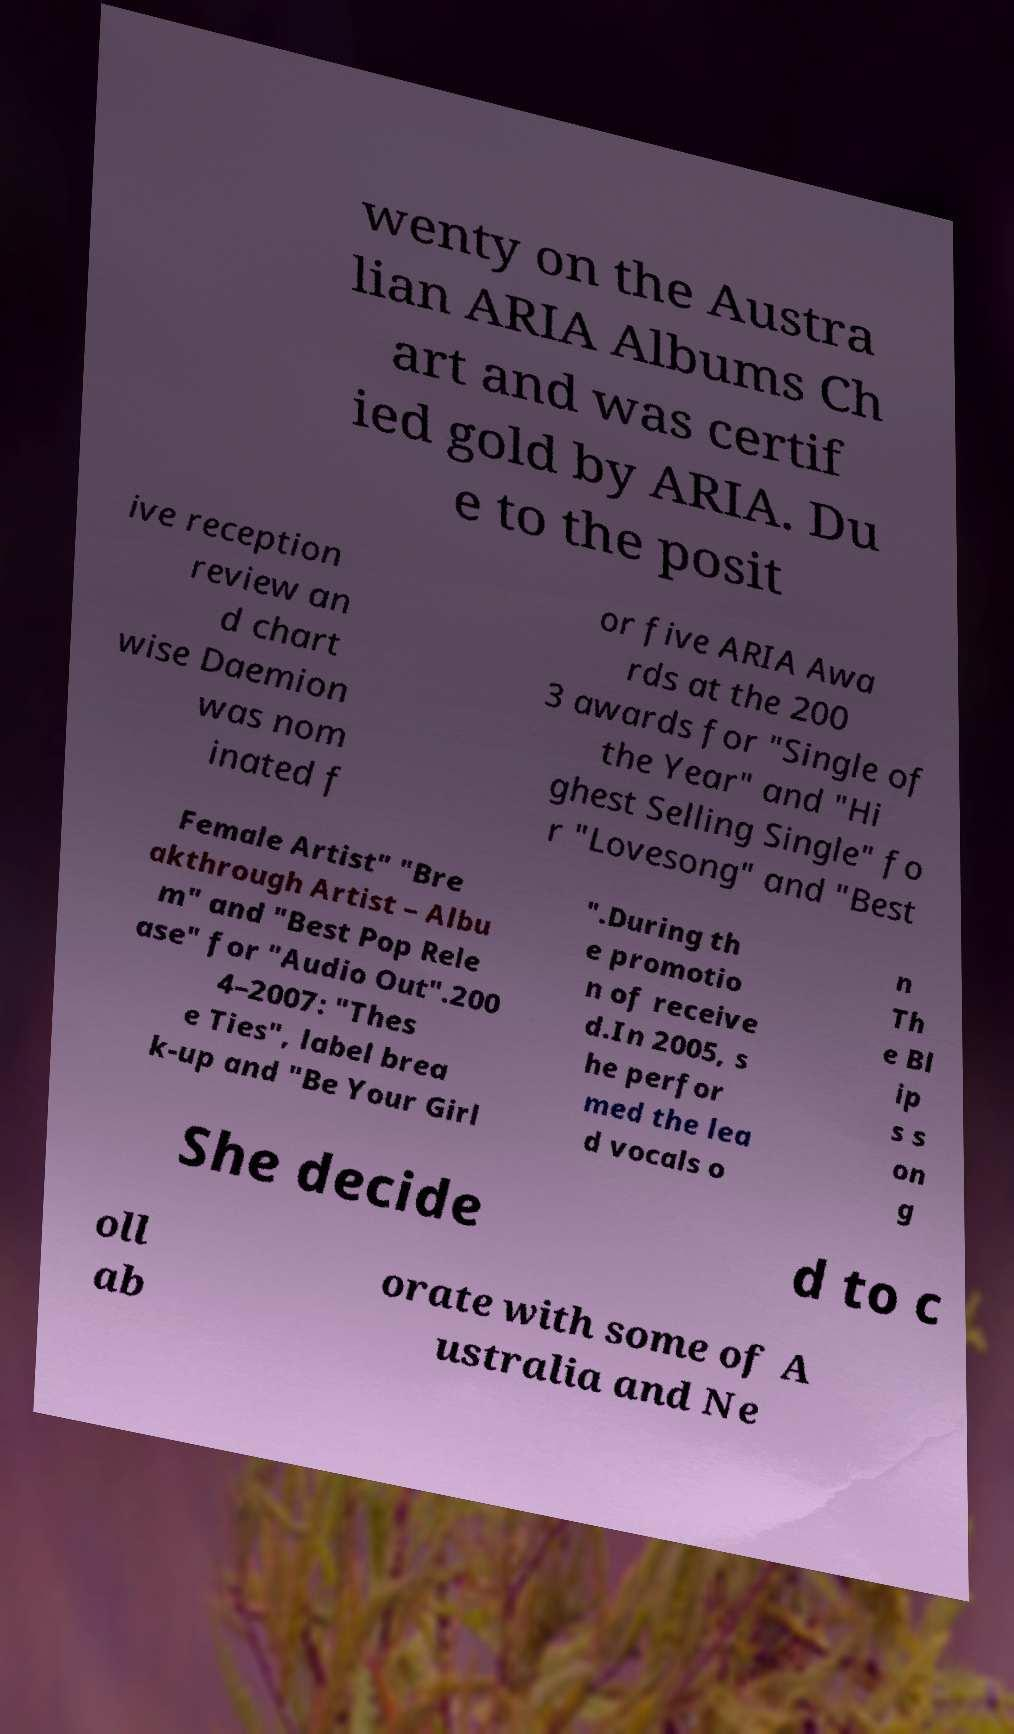There's text embedded in this image that I need extracted. Can you transcribe it verbatim? wenty on the Austra lian ARIA Albums Ch art and was certif ied gold by ARIA. Du e to the posit ive reception review an d chart wise Daemion was nom inated f or five ARIA Awa rds at the 200 3 awards for "Single of the Year" and "Hi ghest Selling Single" fo r "Lovesong" and "Best Female Artist" "Bre akthrough Artist – Albu m" and "Best Pop Rele ase" for "Audio Out".200 4–2007: "Thes e Ties", label brea k-up and "Be Your Girl ".During th e promotio n of receive d.In 2005, s he perfor med the lea d vocals o n Th e Bl ip s s on g She decide d to c oll ab orate with some of A ustralia and Ne 